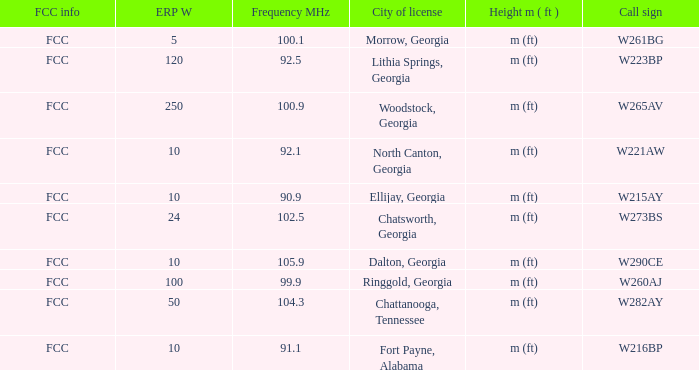Can you parse all the data within this table? {'header': ['FCC info', 'ERP W', 'Frequency MHz', 'City of license', 'Height m ( ft )', 'Call sign'], 'rows': [['FCC', '5', '100.1', 'Morrow, Georgia', 'm (ft)', 'W261BG'], ['FCC', '120', '92.5', 'Lithia Springs, Georgia', 'm (ft)', 'W223BP'], ['FCC', '250', '100.9', 'Woodstock, Georgia', 'm (ft)', 'W265AV'], ['FCC', '10', '92.1', 'North Canton, Georgia', 'm (ft)', 'W221AW'], ['FCC', '10', '90.9', 'Ellijay, Georgia', 'm (ft)', 'W215AY'], ['FCC', '24', '102.5', 'Chatsworth, Georgia', 'm (ft)', 'W273BS'], ['FCC', '10', '105.9', 'Dalton, Georgia', 'm (ft)', 'W290CE'], ['FCC', '100', '99.9', 'Ringgold, Georgia', 'm (ft)', 'W260AJ'], ['FCC', '50', '104.3', 'Chattanooga, Tennessee', 'm (ft)', 'W282AY'], ['FCC', '10', '91.1', 'Fort Payne, Alabama', 'm (ft)', 'W216BP']]} What is the lowest ERP W of  w223bp? 120.0. 